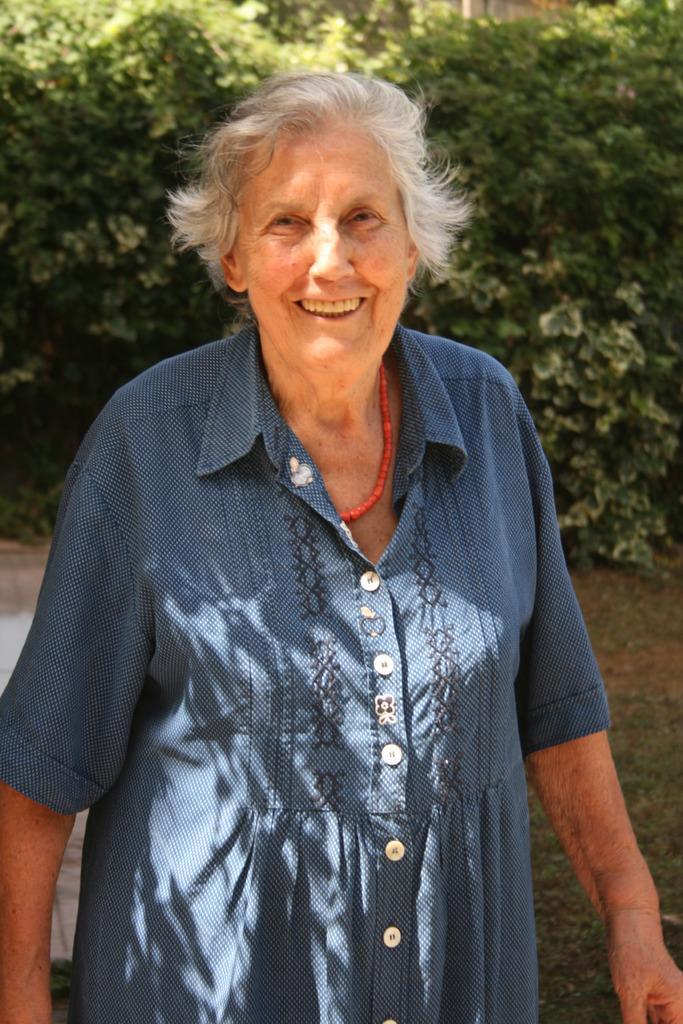Please provide a concise description of this image. In this picture, there is a woman wearing blue dress. Behind her, there are plants. 